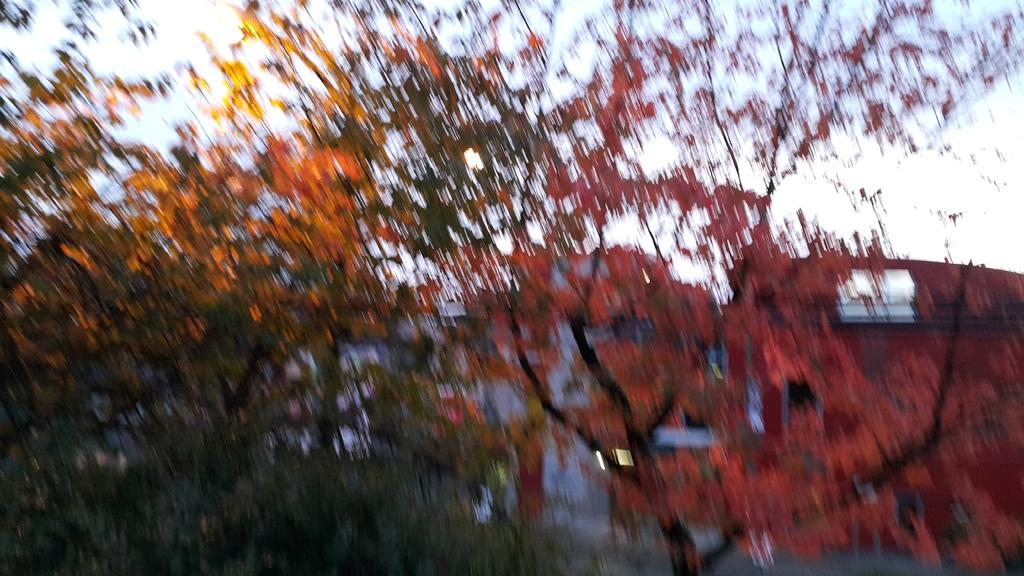What type of vegetation is in the foreground of the image? There are trees in the foreground of the image. What type of structure can be seen in the background of the image? There appears to be a building in the background of the image. What is visible in the sky in the image? The sky is visible in the background of the image. Reasoning: Let's think step by step by step in order to produce the conversation. We start by identifying the main subjects and objects in the image based on the provided facts. We then formulate questions that focus on the location and characteristics of these subjects and objects, ensuring that each question can be answered definitively with the information given. We avoid yes/no questions and ensure that the language is simple and clear. Absurd Question/Answer: What is the fifth tree in the image doing? There is no indication of a fifth tree in the image, nor any specific actions attributed to any of the trees. What is the father's occupation in the image? There is no father or occupation mentioned or depicted in the image. Is there an office visible in the image? There is no office present in the image. 